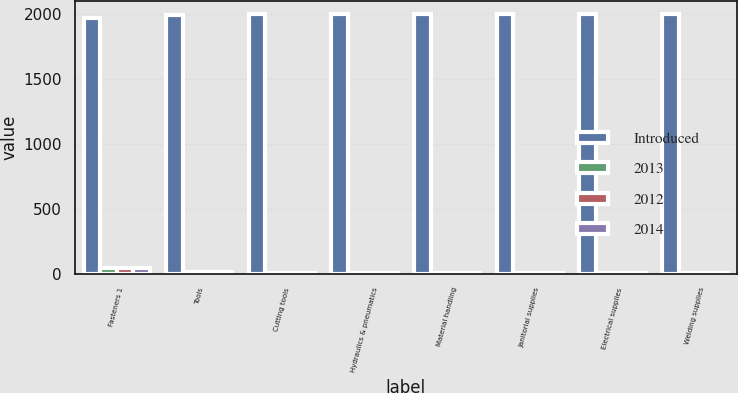Convert chart. <chart><loc_0><loc_0><loc_500><loc_500><stacked_bar_chart><ecel><fcel>Fasteners 1<fcel>Tools<fcel>Cutting tools<fcel>Hydraulics & pneumatics<fcel>Material handling<fcel>Janitorial supplies<fcel>Electrical supplies<fcel>Welding supplies<nl><fcel>Introduced<fcel>1967<fcel>1993<fcel>1996<fcel>1996<fcel>1996<fcel>1996<fcel>1997<fcel>1997<nl><fcel>2013<fcel>40.2<fcel>9.3<fcel>5.5<fcel>7.2<fcel>6.1<fcel>7.3<fcel>4.7<fcel>4.7<nl><fcel>2012<fcel>42.1<fcel>9.2<fcel>5.4<fcel>7.3<fcel>5.7<fcel>7<fcel>4.6<fcel>4.5<nl><fcel>2014<fcel>44<fcel>9.3<fcel>5.1<fcel>7.6<fcel>6<fcel>6.6<fcel>4.7<fcel>4.3<nl></chart> 